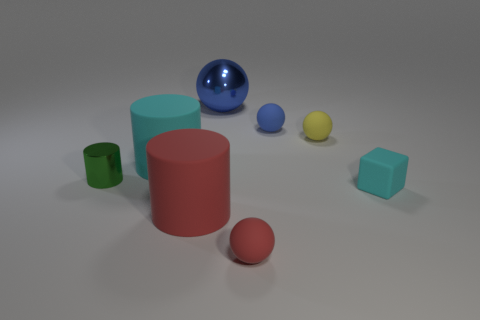How many other objects are there of the same shape as the large red matte object?
Make the answer very short. 2. Is the shape of the blue matte object the same as the cyan matte object on the right side of the large metal thing?
Your answer should be very brief. No. What number of tiny blue objects are to the right of the large cyan rubber object?
Provide a succinct answer. 1. Is there anything else that has the same material as the green cylinder?
Provide a short and direct response. Yes. Is the shape of the small object that is in front of the block the same as  the small blue rubber thing?
Offer a very short reply. Yes. The cylinder that is behind the green shiny cylinder is what color?
Give a very brief answer. Cyan. What shape is the cyan object that is made of the same material as the block?
Provide a succinct answer. Cylinder. Is there any other thing of the same color as the metallic sphere?
Keep it short and to the point. Yes. Are there more big metal things that are right of the cyan block than red matte spheres that are behind the red sphere?
Your answer should be compact. No. What number of blue shiny cylinders have the same size as the red cylinder?
Offer a terse response. 0. 